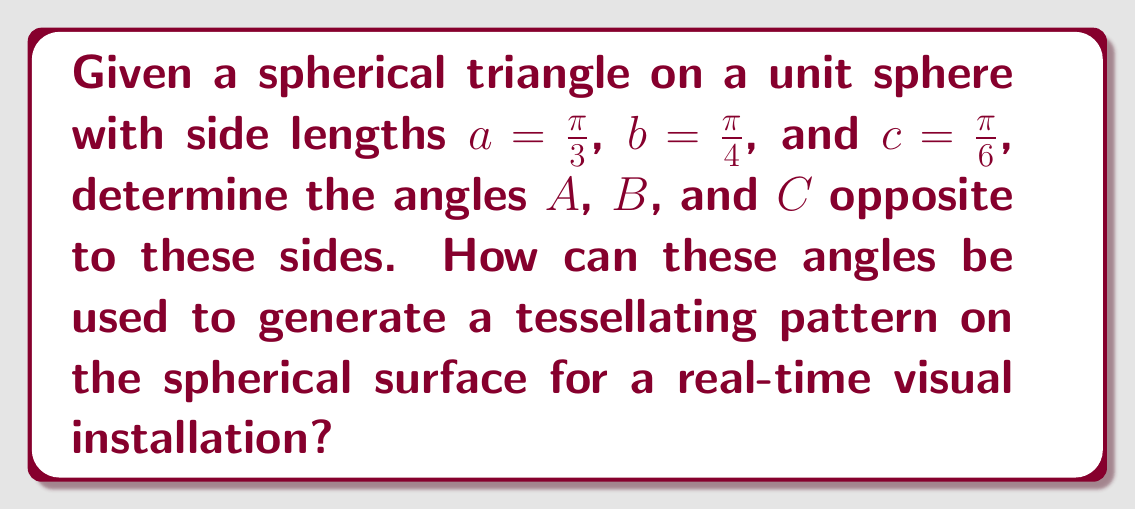Can you answer this question? To solve this problem and create tessellating patterns on curved surfaces, we'll use the spherical law of cosines and follow these steps:

1) The spherical law of cosines states:
   $$\cos(a) = \cos(b)\cos(c) + \sin(b)\sin(c)\cos(A)$$

2) We can rearrange this to solve for $\cos(A)$:
   $$\cos(A) = \frac{\cos(a) - \cos(b)\cos(c)}{\sin(b)\sin(c)}$$

3) Plug in the given values:
   $a = \frac{\pi}{3}$, $b = \frac{\pi}{4}$, $c = \frac{\pi}{6}$

4) Calculate $\cos(A)$:
   $$\cos(A) = \frac{\cos(\frac{\pi}{3}) - \cos(\frac{\pi}{4})\cos(\frac{\pi}{6})}{\sin(\frac{\pi}{4})\sin(\frac{\pi}{6})}$$

5) Evaluate this expression (you can use a calculator):
   $$\cos(A) \approx 0.2679$$

6) Take the arccos to find $A$:
   $$A = \arccos(0.2679) \approx 1.3002 \text{ radians} \approx 74.5°$$

7) Repeat steps 4-6 for angles $B$ and $C$, using the appropriate permutations of $a$, $b$, and $c$.

8) You'll find:
   $B \approx 1.0472 \text{ radians} \approx 60°$
   $C \approx 0.7227 \text{ radians} \approx 41.4°$

9) To generate a tessellating pattern, use these angles to create spherical triangles that can be repeated across the surface. The sum of these angles ($175.9°$) exceeds $180°$, which is characteristic of spherical geometry and allows for tessellation on curved surfaces.

10) For real-time visual installations, implement these calculations in a shader program. Use spherical coordinates to map the pattern onto the curved surface, adjusting the triangle sizes and orientations based on their position on the sphere.
Answer: $A \approx 74.5°$, $B \approx 60°$, $C \approx 41.4°$ 